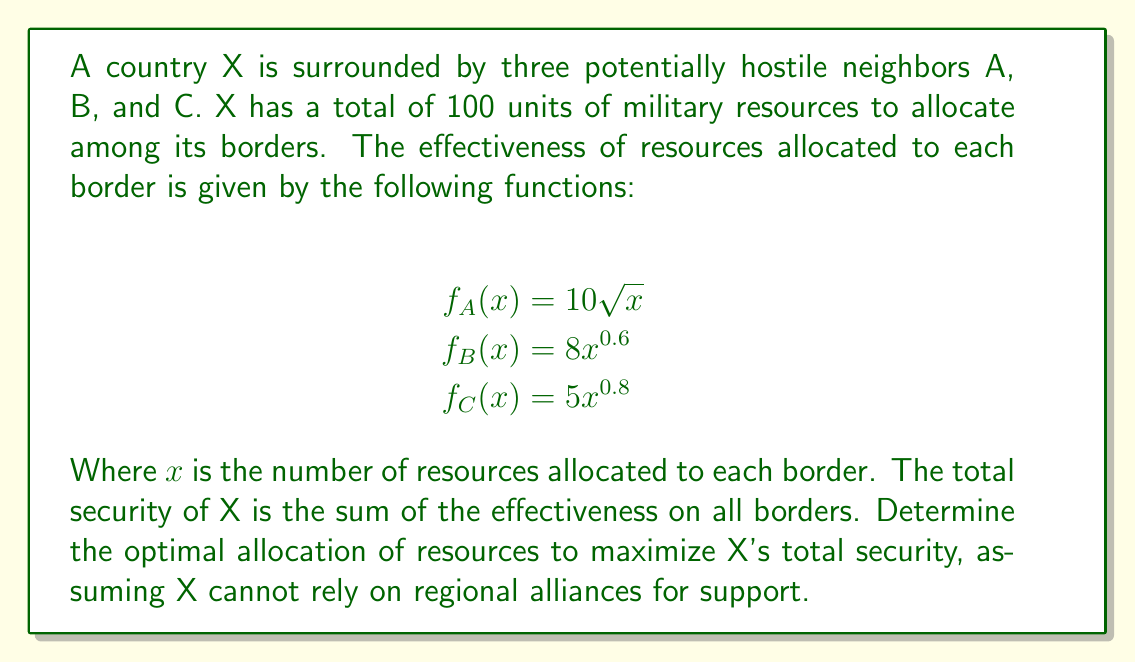Help me with this question. To solve this problem, we need to use the method of Lagrange multipliers, as we are maximizing a function subject to a constraint.

Let $x$, $y$, and $z$ be the resources allocated to borders A, B, and C respectively.

Our objective function is:
$$S(x,y,z) = 10\sqrt{x} + 8y^{0.6} + 5z^{0.8}$$

Subject to the constraint:
$$x + y + z = 100$$

We form the Lagrangian:
$$L(x,y,z,\lambda) = 10\sqrt{x} + 8y^{0.6} + 5z^{0.8} - \lambda(x + y + z - 100)$$

Taking partial derivatives and setting them to zero:

$$\frac{\partial L}{\partial x} = \frac{5}{\sqrt{x}} - \lambda = 0$$
$$\frac{\partial L}{\partial y} = \frac{4.8}{y^{0.4}} - \lambda = 0$$
$$\frac{\partial L}{\partial z} = \frac{4}{z^{0.2}} - \lambda = 0$$
$$\frac{\partial L}{\partial \lambda} = x + y + z - 100 = 0$$

From these equations, we can derive:

$$\frac{5}{\sqrt{x}} = \frac{4.8}{y^{0.4}} = \frac{4}{z^{0.2}} = \lambda$$

This implies:

$$x = \frac{25}{\lambda^2}, y = (\frac{4.8}{\lambda})^{\frac{5}{3}}, z = (\frac{4}{\lambda})^{\frac{5}{4}}$$

Substituting these into the constraint equation:

$$\frac{25}{\lambda^2} + (\frac{4.8}{\lambda})^{\frac{5}{3}} + (\frac{4}{\lambda})^{\frac{5}{4}} = 100$$

This equation can be solved numerically to find $\lambda \approx 0.9205$.

Using this value, we can calculate the optimal allocation:

$$x \approx 29.5, y \approx 37.8, z \approx 32.7$$
Answer: The optimal resource allocation is approximately 29.5 units to border A, 37.8 units to border B, and 32.7 units to border C. 